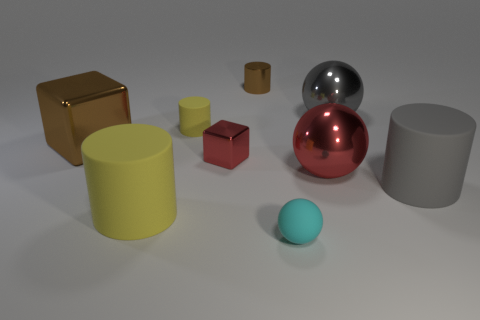What number of balls are tiny things or metallic objects?
Give a very brief answer. 3. What is the color of the small cylinder that is the same material as the tiny cyan ball?
Provide a succinct answer. Yellow. Are there fewer cyan cylinders than tiny rubber spheres?
Provide a succinct answer. Yes. There is a red thing on the left side of the small matte sphere; does it have the same shape as the large brown object behind the gray matte cylinder?
Ensure brevity in your answer.  Yes. How many things are big brown matte cylinders or tiny red cubes?
Ensure brevity in your answer.  1. There is another cylinder that is the same size as the gray rubber cylinder; what color is it?
Provide a short and direct response. Yellow. How many gray objects are behind the small rubber object that is on the left side of the small ball?
Offer a very short reply. 1. How many objects are behind the large gray metallic sphere and in front of the large red metal ball?
Offer a terse response. 0. What number of objects are either shiny blocks on the right side of the large brown shiny thing or red shiny things on the left side of the small brown cylinder?
Give a very brief answer. 1. What number of other things are there of the same size as the metal cylinder?
Offer a terse response. 3. 